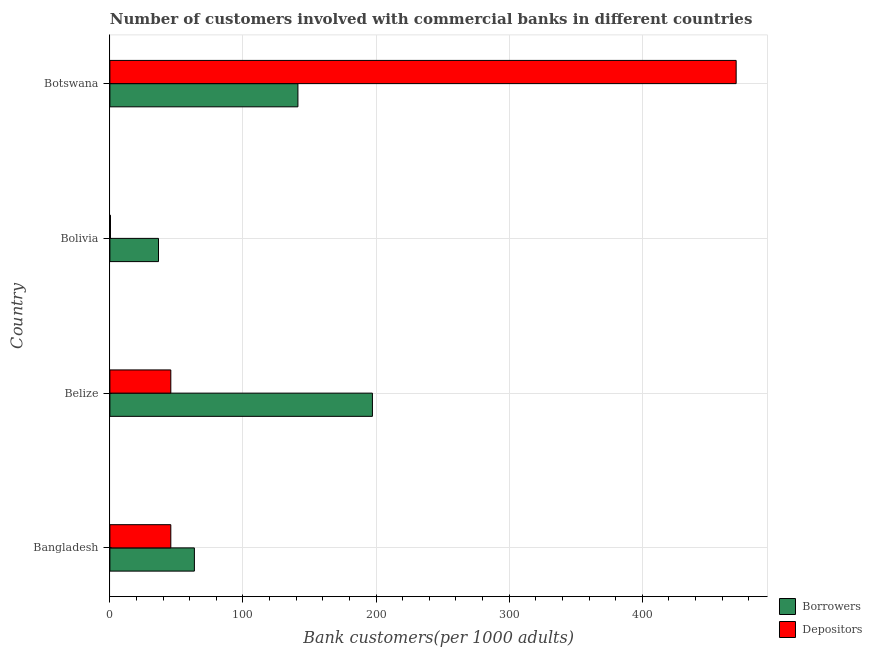How many different coloured bars are there?
Your answer should be very brief. 2. Are the number of bars on each tick of the Y-axis equal?
Keep it short and to the point. Yes. How many bars are there on the 1st tick from the bottom?
Make the answer very short. 2. What is the label of the 1st group of bars from the top?
Offer a very short reply. Botswana. What is the number of depositors in Bangladesh?
Keep it short and to the point. 45.78. Across all countries, what is the maximum number of borrowers?
Your response must be concise. 197.26. Across all countries, what is the minimum number of depositors?
Your answer should be very brief. 0.44. In which country was the number of borrowers maximum?
Make the answer very short. Belize. In which country was the number of depositors minimum?
Offer a very short reply. Bolivia. What is the total number of depositors in the graph?
Provide a succinct answer. 562.57. What is the difference between the number of depositors in Bangladesh and that in Botswana?
Your answer should be compact. -424.8. What is the difference between the number of borrowers in Bolivia and the number of depositors in Belize?
Offer a terse response. -9.26. What is the average number of depositors per country?
Ensure brevity in your answer.  140.64. What is the difference between the number of depositors and number of borrowers in Belize?
Make the answer very short. -151.48. In how many countries, is the number of depositors greater than 360 ?
Give a very brief answer. 1. What is the ratio of the number of depositors in Bangladesh to that in Bolivia?
Offer a very short reply. 104.17. Is the number of depositors in Belize less than that in Botswana?
Your response must be concise. Yes. Is the difference between the number of borrowers in Bangladesh and Botswana greater than the difference between the number of depositors in Bangladesh and Botswana?
Make the answer very short. Yes. What is the difference between the highest and the second highest number of depositors?
Keep it short and to the point. 424.8. What is the difference between the highest and the lowest number of depositors?
Provide a short and direct response. 470.13. In how many countries, is the number of depositors greater than the average number of depositors taken over all countries?
Ensure brevity in your answer.  1. Is the sum of the number of depositors in Belize and Bolivia greater than the maximum number of borrowers across all countries?
Your response must be concise. No. What does the 2nd bar from the top in Belize represents?
Keep it short and to the point. Borrowers. What does the 2nd bar from the bottom in Bangladesh represents?
Make the answer very short. Depositors. Are all the bars in the graph horizontal?
Your answer should be compact. Yes. How many countries are there in the graph?
Provide a short and direct response. 4. What is the difference between two consecutive major ticks on the X-axis?
Provide a succinct answer. 100. Does the graph contain any zero values?
Your answer should be very brief. No. Does the graph contain grids?
Offer a terse response. Yes. Where does the legend appear in the graph?
Your answer should be compact. Bottom right. What is the title of the graph?
Provide a short and direct response. Number of customers involved with commercial banks in different countries. Does "% of GNI" appear as one of the legend labels in the graph?
Your response must be concise. No. What is the label or title of the X-axis?
Ensure brevity in your answer.  Bank customers(per 1000 adults). What is the Bank customers(per 1000 adults) of Borrowers in Bangladesh?
Give a very brief answer. 63.49. What is the Bank customers(per 1000 adults) of Depositors in Bangladesh?
Provide a succinct answer. 45.78. What is the Bank customers(per 1000 adults) of Borrowers in Belize?
Offer a terse response. 197.26. What is the Bank customers(per 1000 adults) of Depositors in Belize?
Provide a succinct answer. 45.78. What is the Bank customers(per 1000 adults) of Borrowers in Bolivia?
Your answer should be very brief. 36.52. What is the Bank customers(per 1000 adults) of Depositors in Bolivia?
Offer a very short reply. 0.44. What is the Bank customers(per 1000 adults) of Borrowers in Botswana?
Make the answer very short. 141.29. What is the Bank customers(per 1000 adults) of Depositors in Botswana?
Your response must be concise. 470.57. Across all countries, what is the maximum Bank customers(per 1000 adults) of Borrowers?
Ensure brevity in your answer.  197.26. Across all countries, what is the maximum Bank customers(per 1000 adults) in Depositors?
Ensure brevity in your answer.  470.57. Across all countries, what is the minimum Bank customers(per 1000 adults) of Borrowers?
Your answer should be very brief. 36.52. Across all countries, what is the minimum Bank customers(per 1000 adults) of Depositors?
Make the answer very short. 0.44. What is the total Bank customers(per 1000 adults) in Borrowers in the graph?
Provide a succinct answer. 438.56. What is the total Bank customers(per 1000 adults) in Depositors in the graph?
Keep it short and to the point. 562.57. What is the difference between the Bank customers(per 1000 adults) in Borrowers in Bangladesh and that in Belize?
Offer a terse response. -133.76. What is the difference between the Bank customers(per 1000 adults) of Borrowers in Bangladesh and that in Bolivia?
Provide a short and direct response. 26.97. What is the difference between the Bank customers(per 1000 adults) in Depositors in Bangladesh and that in Bolivia?
Your response must be concise. 45.34. What is the difference between the Bank customers(per 1000 adults) of Borrowers in Bangladesh and that in Botswana?
Offer a very short reply. -77.79. What is the difference between the Bank customers(per 1000 adults) in Depositors in Bangladesh and that in Botswana?
Offer a very short reply. -424.8. What is the difference between the Bank customers(per 1000 adults) of Borrowers in Belize and that in Bolivia?
Offer a terse response. 160.74. What is the difference between the Bank customers(per 1000 adults) in Depositors in Belize and that in Bolivia?
Offer a terse response. 45.34. What is the difference between the Bank customers(per 1000 adults) in Borrowers in Belize and that in Botswana?
Make the answer very short. 55.97. What is the difference between the Bank customers(per 1000 adults) in Depositors in Belize and that in Botswana?
Your response must be concise. -424.8. What is the difference between the Bank customers(per 1000 adults) in Borrowers in Bolivia and that in Botswana?
Provide a succinct answer. -104.77. What is the difference between the Bank customers(per 1000 adults) in Depositors in Bolivia and that in Botswana?
Your response must be concise. -470.13. What is the difference between the Bank customers(per 1000 adults) in Borrowers in Bangladesh and the Bank customers(per 1000 adults) in Depositors in Belize?
Your answer should be very brief. 17.72. What is the difference between the Bank customers(per 1000 adults) of Borrowers in Bangladesh and the Bank customers(per 1000 adults) of Depositors in Bolivia?
Give a very brief answer. 63.05. What is the difference between the Bank customers(per 1000 adults) in Borrowers in Bangladesh and the Bank customers(per 1000 adults) in Depositors in Botswana?
Keep it short and to the point. -407.08. What is the difference between the Bank customers(per 1000 adults) in Borrowers in Belize and the Bank customers(per 1000 adults) in Depositors in Bolivia?
Your answer should be very brief. 196.82. What is the difference between the Bank customers(per 1000 adults) of Borrowers in Belize and the Bank customers(per 1000 adults) of Depositors in Botswana?
Offer a very short reply. -273.32. What is the difference between the Bank customers(per 1000 adults) in Borrowers in Bolivia and the Bank customers(per 1000 adults) in Depositors in Botswana?
Offer a terse response. -434.05. What is the average Bank customers(per 1000 adults) of Borrowers per country?
Keep it short and to the point. 109.64. What is the average Bank customers(per 1000 adults) in Depositors per country?
Ensure brevity in your answer.  140.64. What is the difference between the Bank customers(per 1000 adults) in Borrowers and Bank customers(per 1000 adults) in Depositors in Bangladesh?
Give a very brief answer. 17.72. What is the difference between the Bank customers(per 1000 adults) in Borrowers and Bank customers(per 1000 adults) in Depositors in Belize?
Your answer should be very brief. 151.48. What is the difference between the Bank customers(per 1000 adults) of Borrowers and Bank customers(per 1000 adults) of Depositors in Bolivia?
Offer a terse response. 36.08. What is the difference between the Bank customers(per 1000 adults) in Borrowers and Bank customers(per 1000 adults) in Depositors in Botswana?
Provide a short and direct response. -329.29. What is the ratio of the Bank customers(per 1000 adults) of Borrowers in Bangladesh to that in Belize?
Provide a succinct answer. 0.32. What is the ratio of the Bank customers(per 1000 adults) in Depositors in Bangladesh to that in Belize?
Provide a succinct answer. 1. What is the ratio of the Bank customers(per 1000 adults) in Borrowers in Bangladesh to that in Bolivia?
Give a very brief answer. 1.74. What is the ratio of the Bank customers(per 1000 adults) in Depositors in Bangladesh to that in Bolivia?
Provide a succinct answer. 104.17. What is the ratio of the Bank customers(per 1000 adults) of Borrowers in Bangladesh to that in Botswana?
Ensure brevity in your answer.  0.45. What is the ratio of the Bank customers(per 1000 adults) in Depositors in Bangladesh to that in Botswana?
Your answer should be very brief. 0.1. What is the ratio of the Bank customers(per 1000 adults) in Borrowers in Belize to that in Bolivia?
Provide a short and direct response. 5.4. What is the ratio of the Bank customers(per 1000 adults) in Depositors in Belize to that in Bolivia?
Ensure brevity in your answer.  104.17. What is the ratio of the Bank customers(per 1000 adults) in Borrowers in Belize to that in Botswana?
Provide a short and direct response. 1.4. What is the ratio of the Bank customers(per 1000 adults) of Depositors in Belize to that in Botswana?
Your response must be concise. 0.1. What is the ratio of the Bank customers(per 1000 adults) in Borrowers in Bolivia to that in Botswana?
Keep it short and to the point. 0.26. What is the ratio of the Bank customers(per 1000 adults) in Depositors in Bolivia to that in Botswana?
Make the answer very short. 0. What is the difference between the highest and the second highest Bank customers(per 1000 adults) in Borrowers?
Give a very brief answer. 55.97. What is the difference between the highest and the second highest Bank customers(per 1000 adults) of Depositors?
Your answer should be very brief. 424.8. What is the difference between the highest and the lowest Bank customers(per 1000 adults) in Borrowers?
Make the answer very short. 160.74. What is the difference between the highest and the lowest Bank customers(per 1000 adults) in Depositors?
Offer a very short reply. 470.13. 